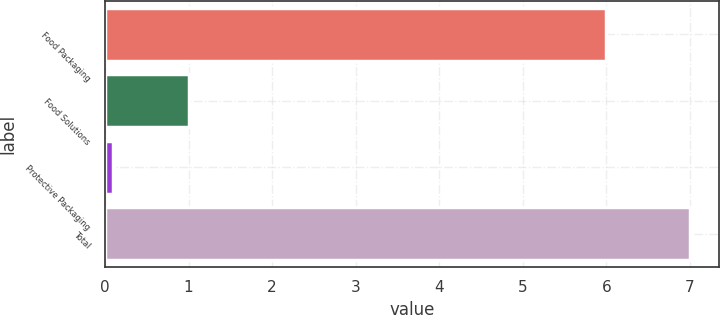Convert chart to OTSL. <chart><loc_0><loc_0><loc_500><loc_500><bar_chart><fcel>Food Packaging<fcel>Food Solutions<fcel>Protective Packaging<fcel>Total<nl><fcel>6<fcel>1<fcel>0.1<fcel>7<nl></chart> 